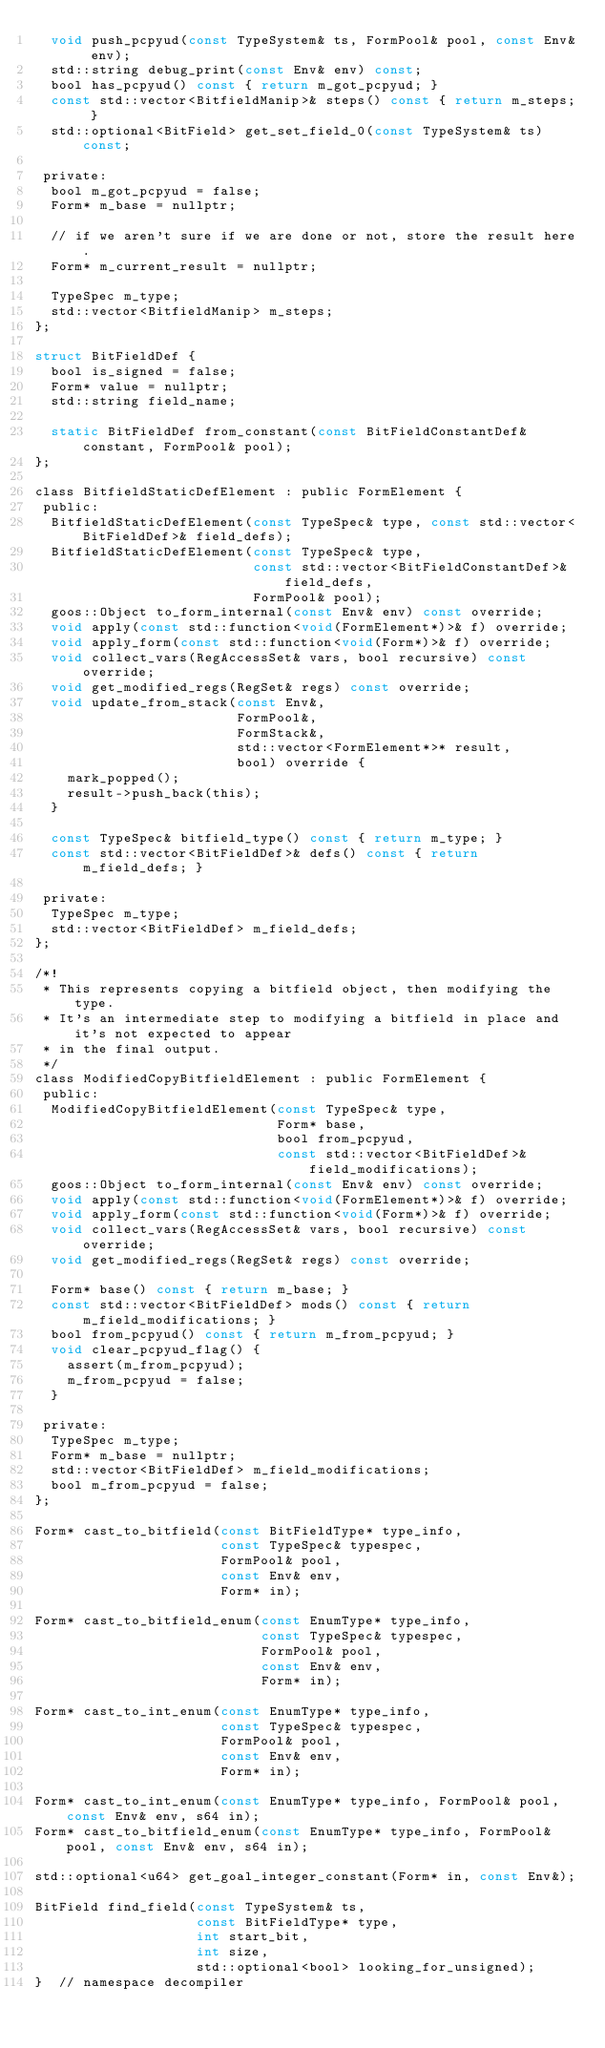<code> <loc_0><loc_0><loc_500><loc_500><_C_>  void push_pcpyud(const TypeSystem& ts, FormPool& pool, const Env& env);
  std::string debug_print(const Env& env) const;
  bool has_pcpyud() const { return m_got_pcpyud; }
  const std::vector<BitfieldManip>& steps() const { return m_steps; }
  std::optional<BitField> get_set_field_0(const TypeSystem& ts) const;

 private:
  bool m_got_pcpyud = false;
  Form* m_base = nullptr;

  // if we aren't sure if we are done or not, store the result here.
  Form* m_current_result = nullptr;

  TypeSpec m_type;
  std::vector<BitfieldManip> m_steps;
};

struct BitFieldDef {
  bool is_signed = false;
  Form* value = nullptr;
  std::string field_name;

  static BitFieldDef from_constant(const BitFieldConstantDef& constant, FormPool& pool);
};

class BitfieldStaticDefElement : public FormElement {
 public:
  BitfieldStaticDefElement(const TypeSpec& type, const std::vector<BitFieldDef>& field_defs);
  BitfieldStaticDefElement(const TypeSpec& type,
                           const std::vector<BitFieldConstantDef>& field_defs,
                           FormPool& pool);
  goos::Object to_form_internal(const Env& env) const override;
  void apply(const std::function<void(FormElement*)>& f) override;
  void apply_form(const std::function<void(Form*)>& f) override;
  void collect_vars(RegAccessSet& vars, bool recursive) const override;
  void get_modified_regs(RegSet& regs) const override;
  void update_from_stack(const Env&,
                         FormPool&,
                         FormStack&,
                         std::vector<FormElement*>* result,
                         bool) override {
    mark_popped();
    result->push_back(this);
  }

  const TypeSpec& bitfield_type() const { return m_type; }
  const std::vector<BitFieldDef>& defs() const { return m_field_defs; }

 private:
  TypeSpec m_type;
  std::vector<BitFieldDef> m_field_defs;
};

/*!
 * This represents copying a bitfield object, then modifying the type.
 * It's an intermediate step to modifying a bitfield in place and it's not expected to appear
 * in the final output.
 */
class ModifiedCopyBitfieldElement : public FormElement {
 public:
  ModifiedCopyBitfieldElement(const TypeSpec& type,
                              Form* base,
                              bool from_pcpyud,
                              const std::vector<BitFieldDef>& field_modifications);
  goos::Object to_form_internal(const Env& env) const override;
  void apply(const std::function<void(FormElement*)>& f) override;
  void apply_form(const std::function<void(Form*)>& f) override;
  void collect_vars(RegAccessSet& vars, bool recursive) const override;
  void get_modified_regs(RegSet& regs) const override;

  Form* base() const { return m_base; }
  const std::vector<BitFieldDef> mods() const { return m_field_modifications; }
  bool from_pcpyud() const { return m_from_pcpyud; }
  void clear_pcpyud_flag() {
    assert(m_from_pcpyud);
    m_from_pcpyud = false;
  }

 private:
  TypeSpec m_type;
  Form* m_base = nullptr;
  std::vector<BitFieldDef> m_field_modifications;
  bool m_from_pcpyud = false;
};

Form* cast_to_bitfield(const BitFieldType* type_info,
                       const TypeSpec& typespec,
                       FormPool& pool,
                       const Env& env,
                       Form* in);

Form* cast_to_bitfield_enum(const EnumType* type_info,
                            const TypeSpec& typespec,
                            FormPool& pool,
                            const Env& env,
                            Form* in);

Form* cast_to_int_enum(const EnumType* type_info,
                       const TypeSpec& typespec,
                       FormPool& pool,
                       const Env& env,
                       Form* in);

Form* cast_to_int_enum(const EnumType* type_info, FormPool& pool, const Env& env, s64 in);
Form* cast_to_bitfield_enum(const EnumType* type_info, FormPool& pool, const Env& env, s64 in);

std::optional<u64> get_goal_integer_constant(Form* in, const Env&);

BitField find_field(const TypeSystem& ts,
                    const BitFieldType* type,
                    int start_bit,
                    int size,
                    std::optional<bool> looking_for_unsigned);
}  // namespace decompiler
</code> 